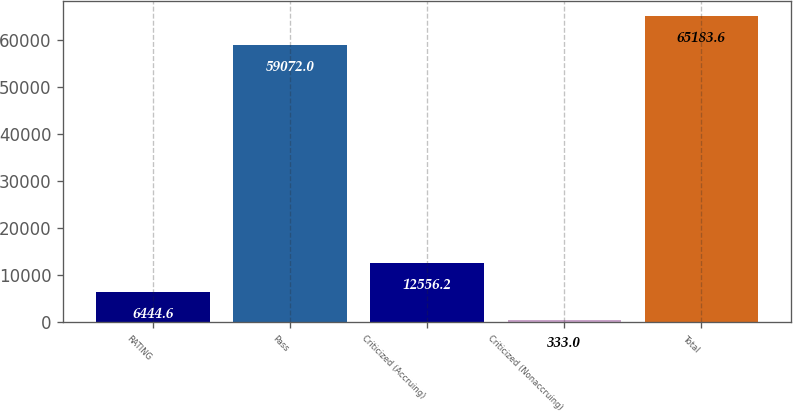Convert chart to OTSL. <chart><loc_0><loc_0><loc_500><loc_500><bar_chart><fcel>RATING<fcel>Pass<fcel>Criticized (Accruing)<fcel>Criticized (Nonaccruing)<fcel>Total<nl><fcel>6444.6<fcel>59072<fcel>12556.2<fcel>333<fcel>65183.6<nl></chart> 